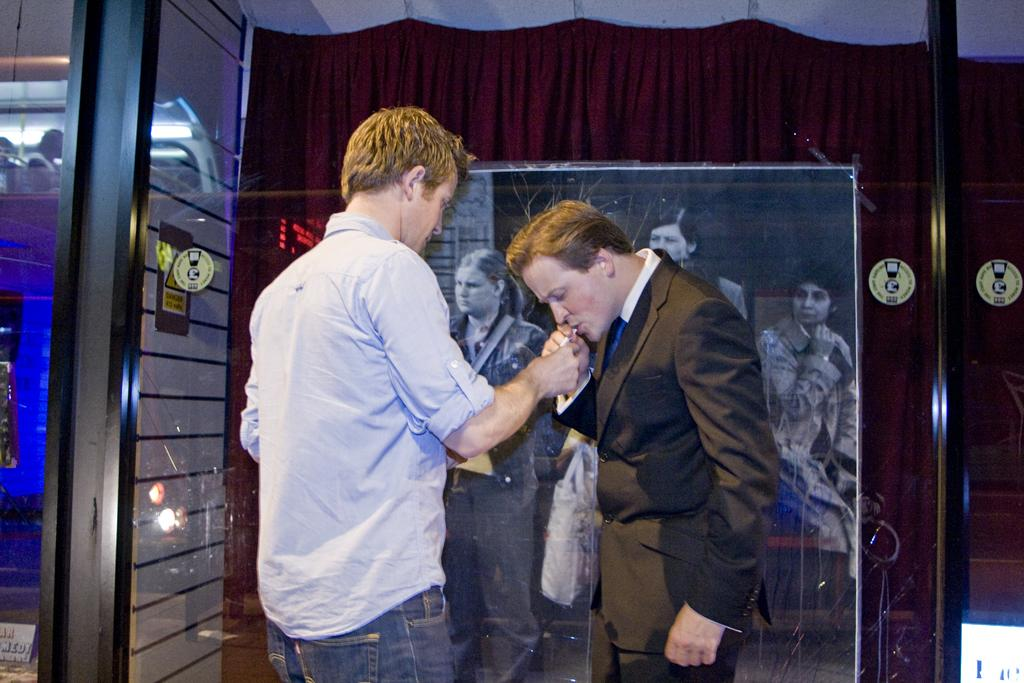What is the main subject of the image? The main subject of the image is men standing on the floor. Can you describe the background of the image? There is a black and white picture attached to a curtain in the background, along with doors and electric lights. How many men are visible in the image? The number of men is not specified, but there are men standing in the image. What type of account does the man on the left have in the image? There is no information about any accounts in the image; it only shows men standing on the floor and a background with a black and white picture, curtain, doors, and electric lights. 